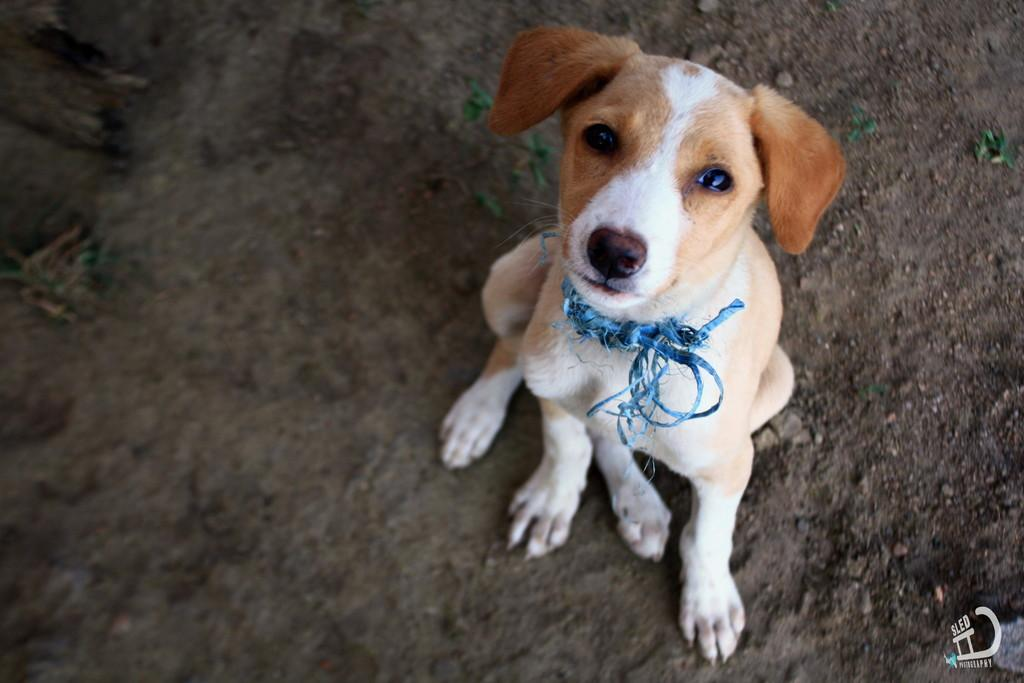What type of animal is in the image? There is a dog in the image. What is the dog doing in the image? The dog is sitting on the ground. What is the dog wearing in the image? The dog is wearing a blue object around its neck. What type of voice does the dog have in the image? Dogs do not have a voice in images, as they are not capable of speaking or making vocalizations in a still photograph. 